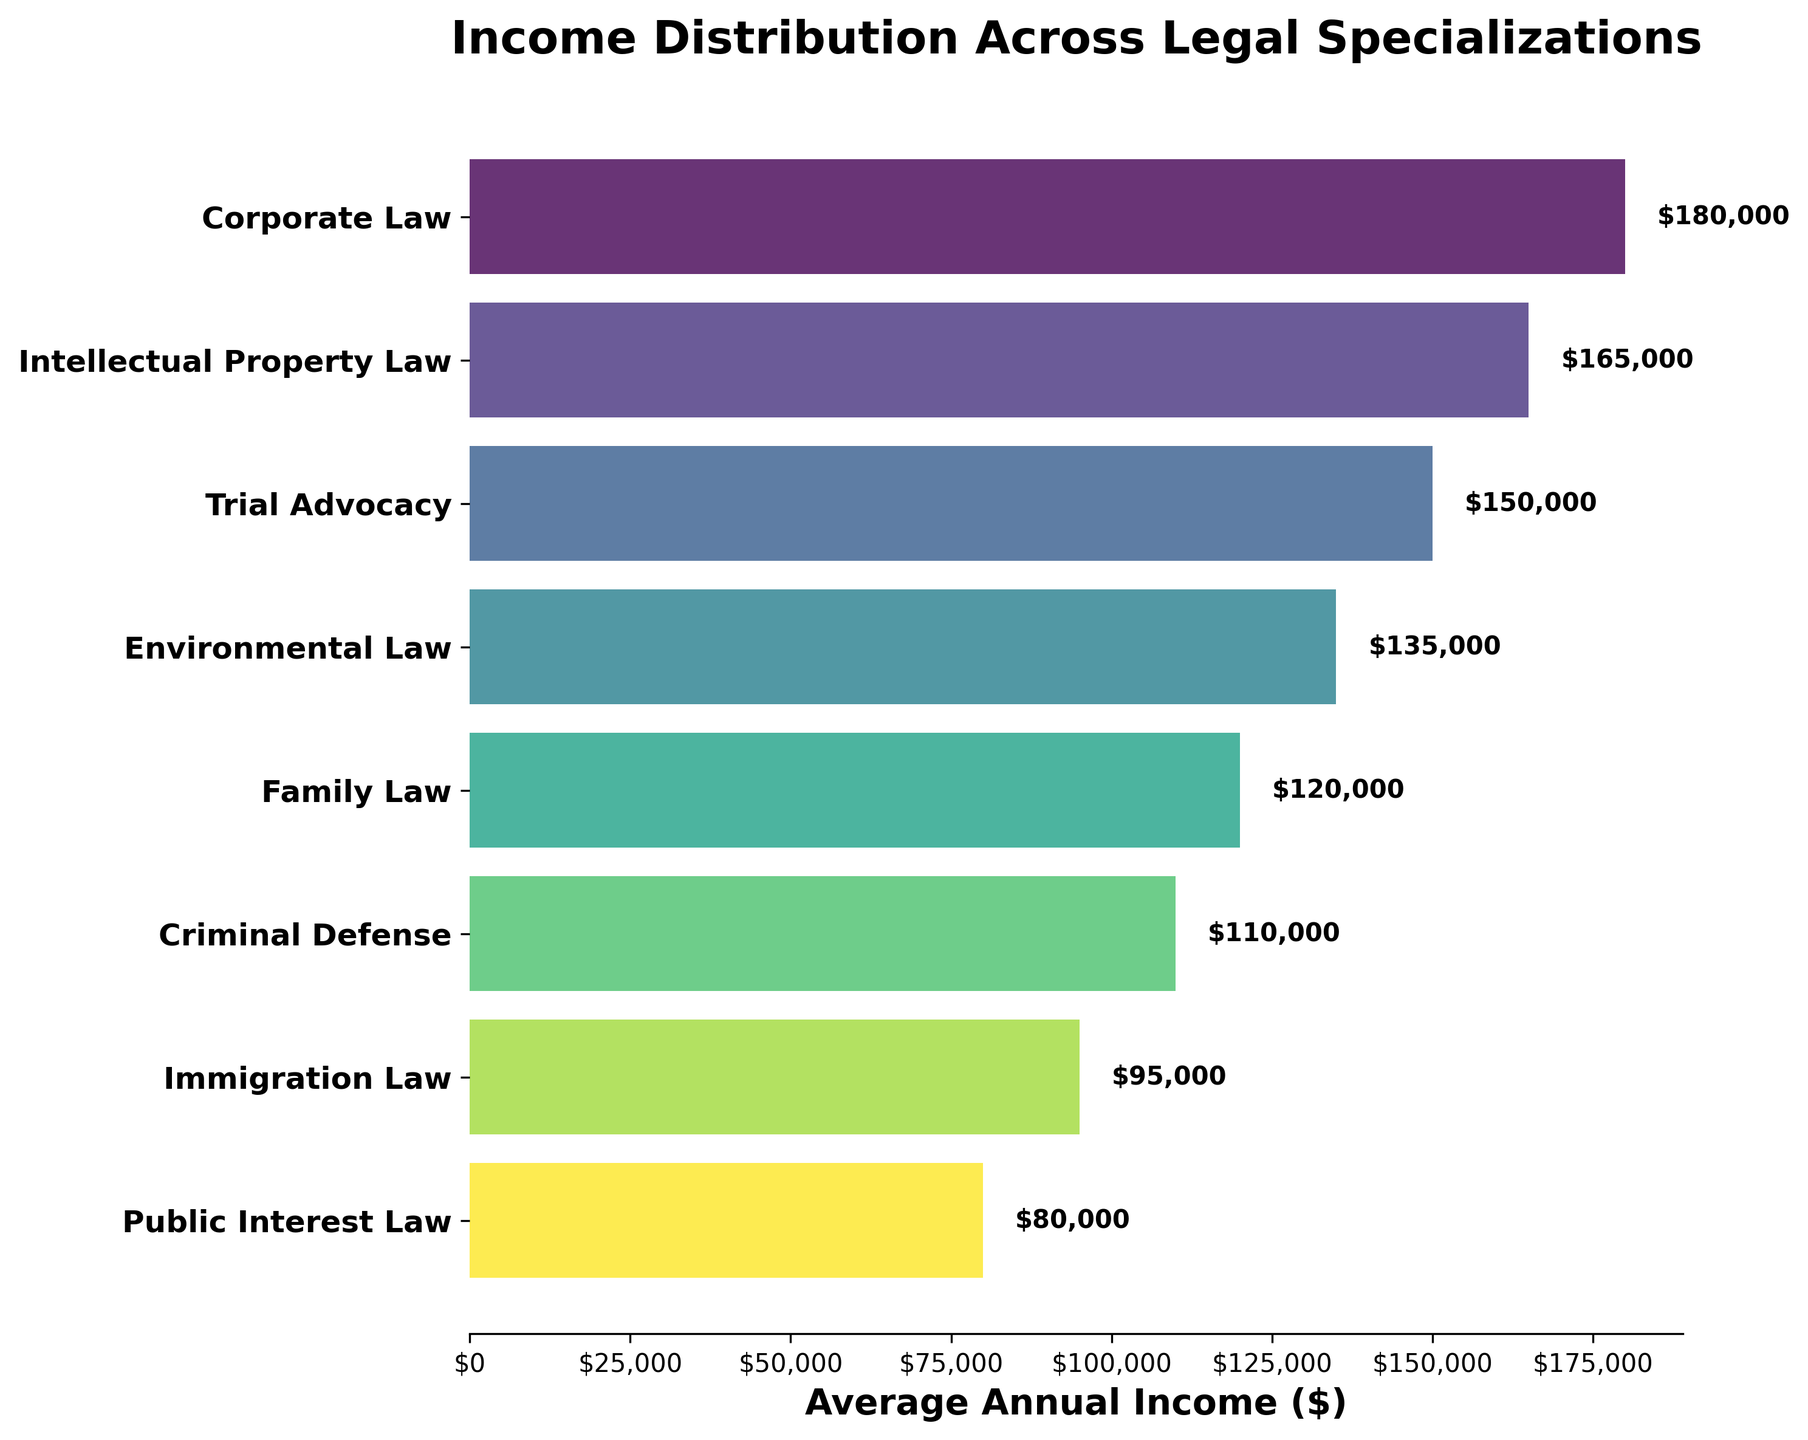what is the title of the funnel chart? The title is usually displayed at the top of the plot. Here, it's "Income Distribution Across Legal Specializations"
Answer: Income Distribution Across Legal Specializations Which legal specialization has the highest average annual income? To find the highest average annual income, look for the longest bar among the specializations. Corporate Law has the longest bar.
Answer: Corporate Law Which legal specialization has the lowest average annual income? To find the lowest average annual income, look for the shortest bar among the specializations. Public Interest Law has the shortest bar.
Answer: Public Interest Law How much more is the average annual income of Intellectual Property Law compared to Criminal Defense? Subtract the average annual income of Criminal Defense from Intellectual Property Law: $165,000 - $110,000.
Answer: $55,000 Which specializations have an average annual income higher than $130,000? Identify specializations whose bars extend beyond the $130,000 mark. Corporate Law, Intellectual Property Law, and Trial Advocacy meet this criterion.
Answer: Corporate Law, Intellectual Property Law, Trial Advocacy Arrange the specializations in ascending order of average annual income. List the specializations from the shortest bar to the longest bar. The sequence is Public Interest Law, Immigration Law, Criminal Defense, Family Law, Environmental Law, Trial Advocacy, Intellectual Property Law, Corporate Law.
Answer: Public Interest Law, Immigration Law, Criminal Defense, Family Law, Environmental Law, Trial Advocacy, Intellectual Property Law, Corporate Law How much is the average annual income for Family Law? Look at the length of the bar associated with Family Law and the value labeled on it, which is $120,000.
Answer: $120,000 What is the difference in average annual income between the highest and lowest earning specializations? Subtract the average annual income of Public Interest Law from Corporate Law: $180,000 - $80,000.
Answer: $100,000 Which legal specialization has an average annual income closest to $140,000? Find the specialization whose bar is closest to the $140,000 mark. Environmental Law has an average income closest to this value.
Answer: Environmental Law Is the average annual income of Trial Advocacy higher than that of Environmental Law? Compare the lengths of the bars for Trial Advocacy and Environmental Law. Trial Advocacy's bar is longer, indicating a higher average income.
Answer: Yes 